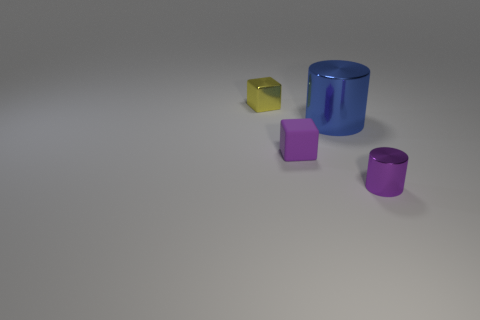There is a small metallic cylinder; is it the same color as the cube in front of the blue thing?
Keep it short and to the point. Yes. What size is the metallic object that is the same color as the small matte object?
Your answer should be very brief. Small. There is a small cube that is the same color as the tiny shiny cylinder; what is it made of?
Make the answer very short. Rubber. Are there fewer small objects behind the small metallic cylinder than things in front of the tiny yellow metal block?
Offer a very short reply. Yes. What number of things are small purple objects on the left side of the small shiny cylinder or big yellow things?
Offer a very short reply. 1. What shape is the metal object that is on the left side of the block that is in front of the yellow shiny object?
Your answer should be compact. Cube. Is there a blue thing that has the same size as the purple metallic cylinder?
Keep it short and to the point. No. Is the number of blue cylinders greater than the number of large red metallic things?
Your answer should be compact. Yes. Does the purple object right of the blue metal thing have the same size as the block that is to the right of the small metallic block?
Keep it short and to the point. Yes. How many tiny blocks are behind the large cylinder and in front of the big metallic thing?
Offer a terse response. 0. 